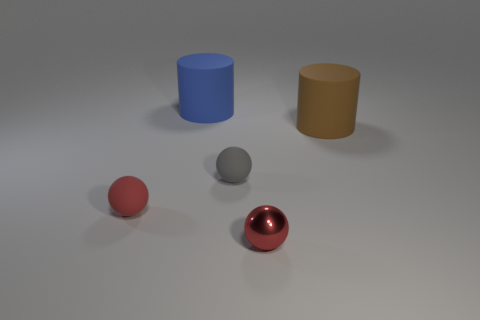Add 3 purple objects. How many objects exist? 8 Subtract all red spheres. How many spheres are left? 1 Subtract all red balls. How many balls are left? 1 Subtract all cylinders. How many objects are left? 3 Subtract all brown blocks. How many red balls are left? 2 Add 4 gray matte balls. How many gray matte balls are left? 5 Add 4 small brown things. How many small brown things exist? 4 Subtract 0 blue balls. How many objects are left? 5 Subtract 2 cylinders. How many cylinders are left? 0 Subtract all red spheres. Subtract all purple cylinders. How many spheres are left? 1 